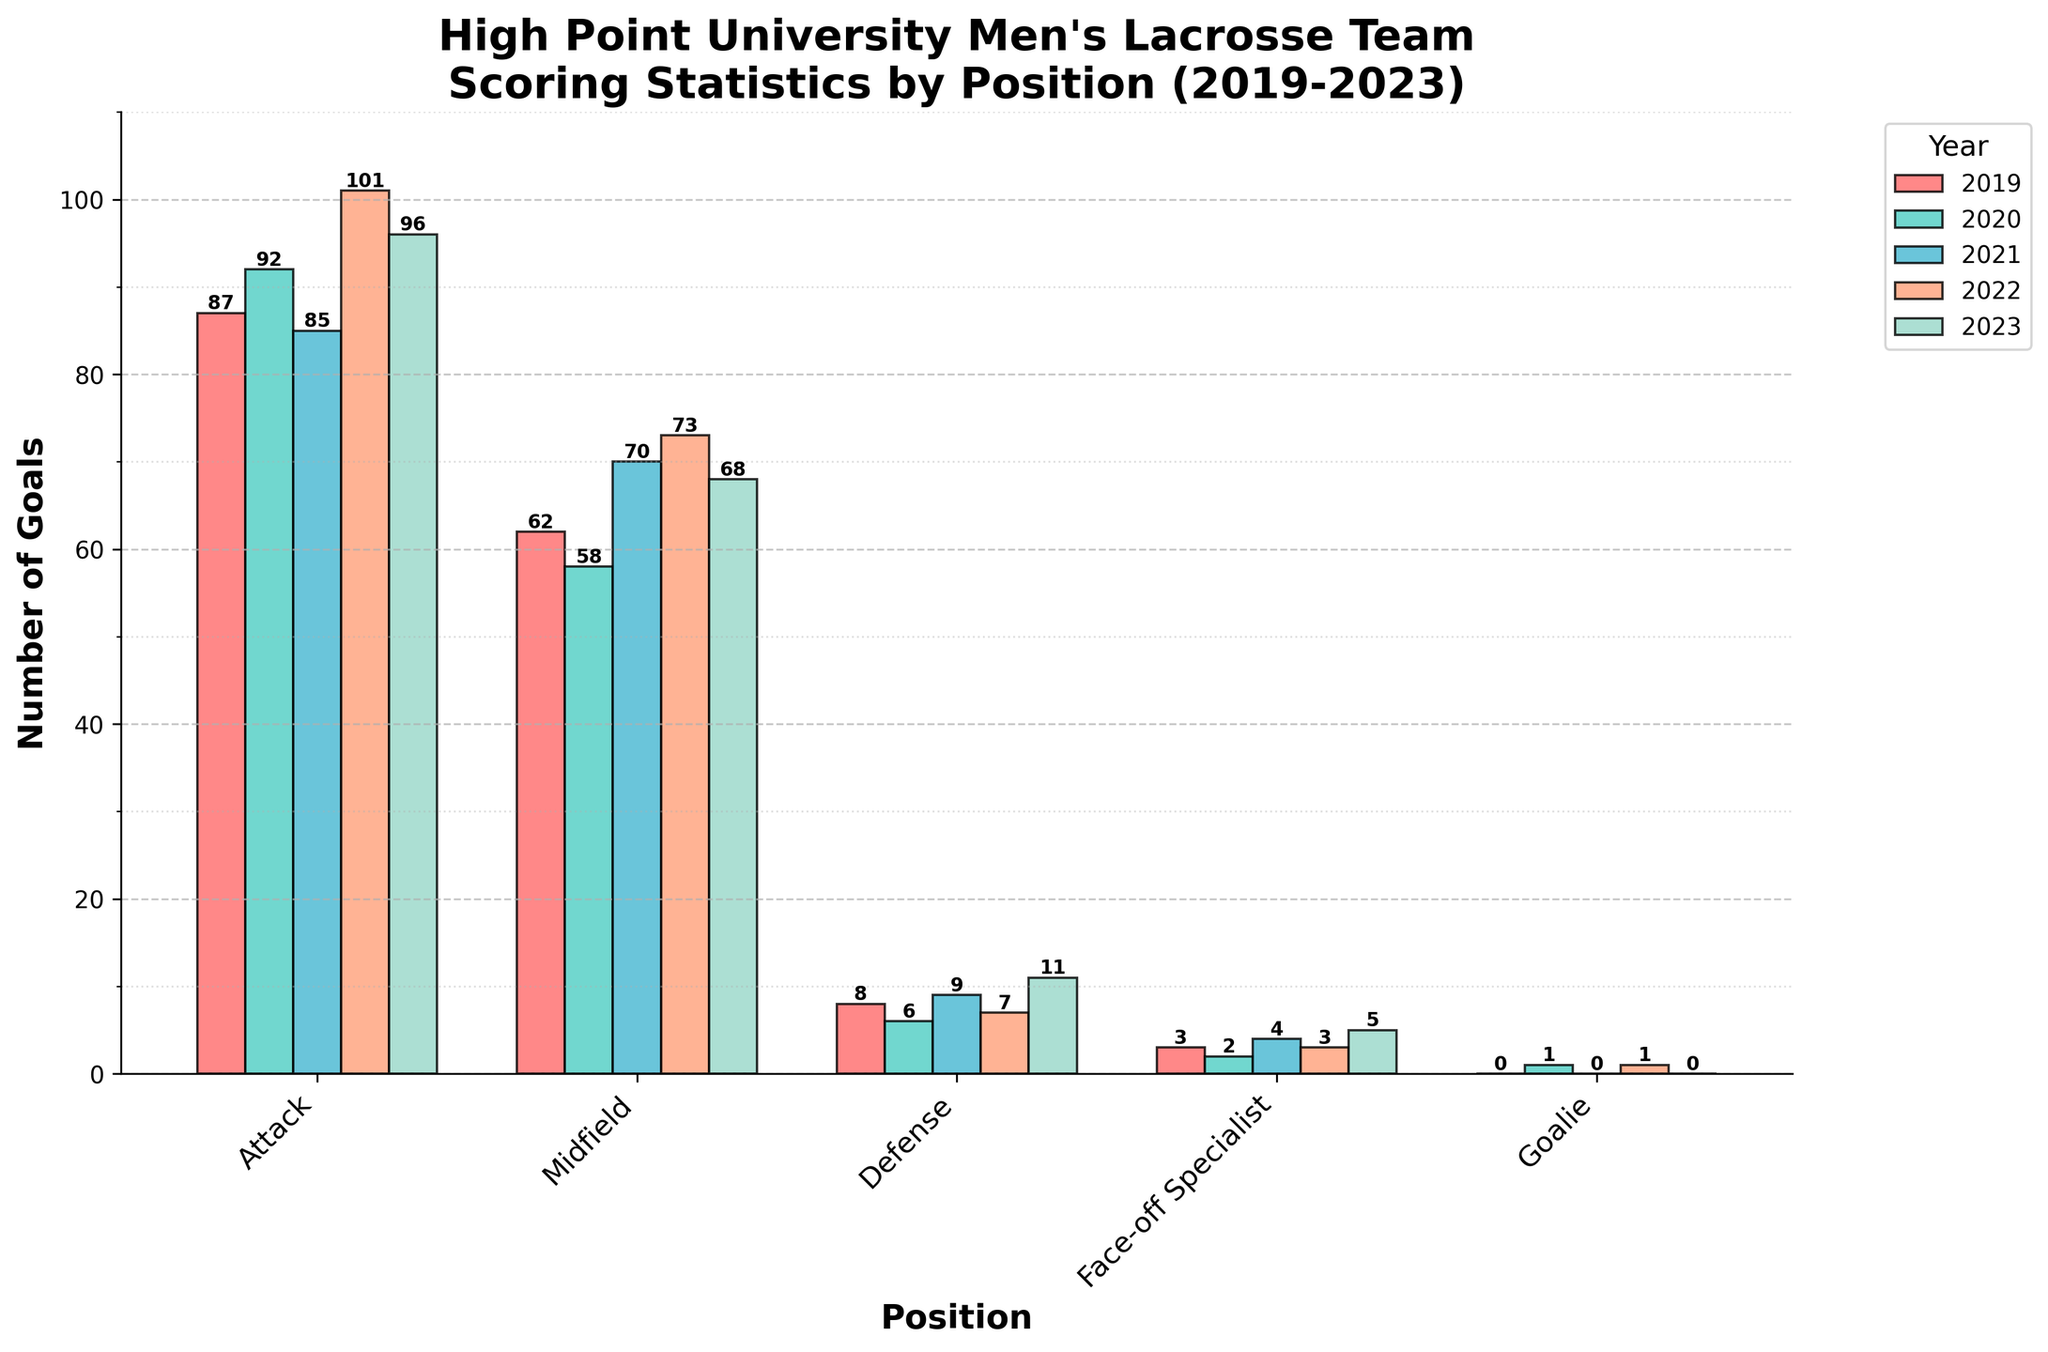Which position scored the most goals in 2023? Look at the bars for the year 2023 and identify the tallest. The Attack position has the highest bar for 2023 with a value of 96.
Answer: Attack Which position scored the fewest goals in 2022? Look at the bars for the year 2022 and identify the shortest. The Goalie position has the lowest bar for 2022 with a value of 1.
Answer: Goalie Which year had the highest total number of goals scored by the Midfield position? Sum the goals scored by the Midfield position for each year and compare. For 2019 (62), 2020 (58), 2021 (70), 2022 (73), and 2023 (68); the year 2022 has the highest total with 73 goals.
Answer: 2022 How many total goals were scored by the Defense position across all years? Add the number of goals scored by the Defense position for each year: 2019 (8), 2020 (6), 2021 (9), 2022 (7), and 2023 (11), which sums up to 41.
Answer: 41 Which year saw a drop in goals scored by the Attack position compared to the previous year? Compare the goals scored by the Attack position year-by-year: between 2019 (87) and 2020 (92), 2020 to 2021 (85), 2021 to 2022 (101), and 2022 to 2023 (96). The drop occurred between 2020 (92) and 2021 (85).
Answer: 2021 Which position saw an increase every year in goals from 2019 to 2023? Evaluate each position's goals over the years. Only the Face-off Specialist position increases every year from 2019 (3) to 2020 (2), 2021 (4), 2022 (3), to 2023 (5).
Answer: Face-off Specialist How much more did the Attack position score in 2022 than the Midfield position in the same year? Subtract the Midfield's 2022 score (73) from the Attack's 2022 score (101): 101 - 73 = 28.
Answer: 28 Which year did the Defense position score the most goals? Look for the highest bar for the Defense position across all years: the year 2023 with 11 goals.
Answer: 2023 By how much did the total goals scored by the Defense and Goalie positions combined in 2023 exceed the same combination in 2019? Add the totals for Defense and Goalie in 2023 (11 + 0 = 11) and in 2019 (8 + 0 = 8). Calculate the difference: 11 - 8 = 3.
Answer: 3 What is the average number of goals scored by Face-off Specialists over the five years? Sum the goals for Face-off Specialists from 2019 to 2023: 3 + 2 + 4 + 3 + 5 = 17. Divide by the number of years: 17 / 5 = 3.4.
Answer: 3.4 